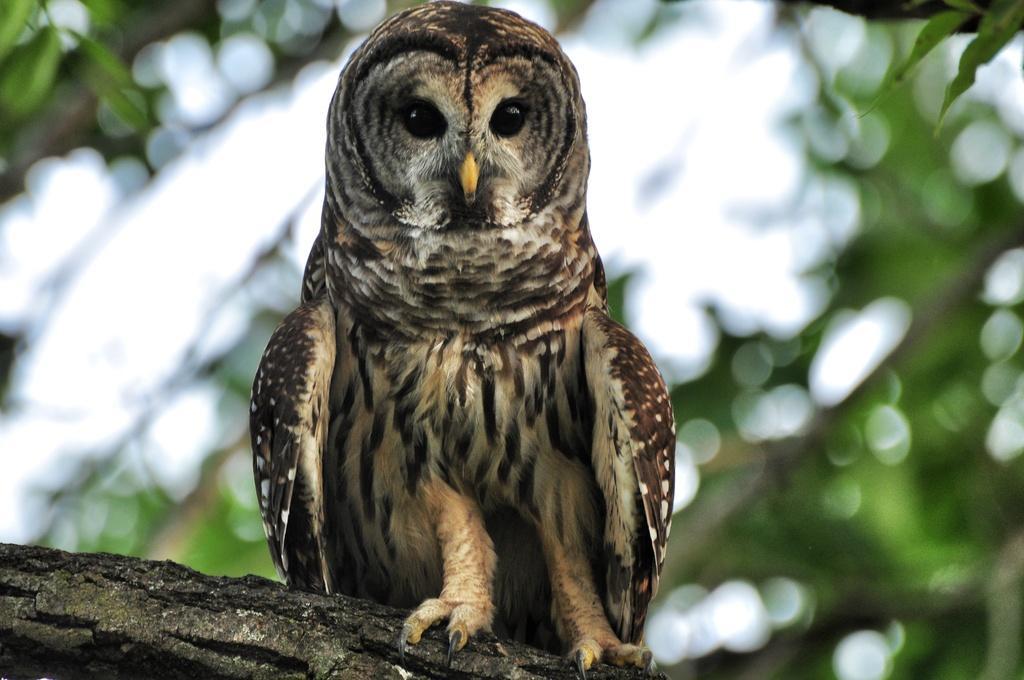Could you give a brief overview of what you see in this image? In this picture we can see an owl on the tree. 